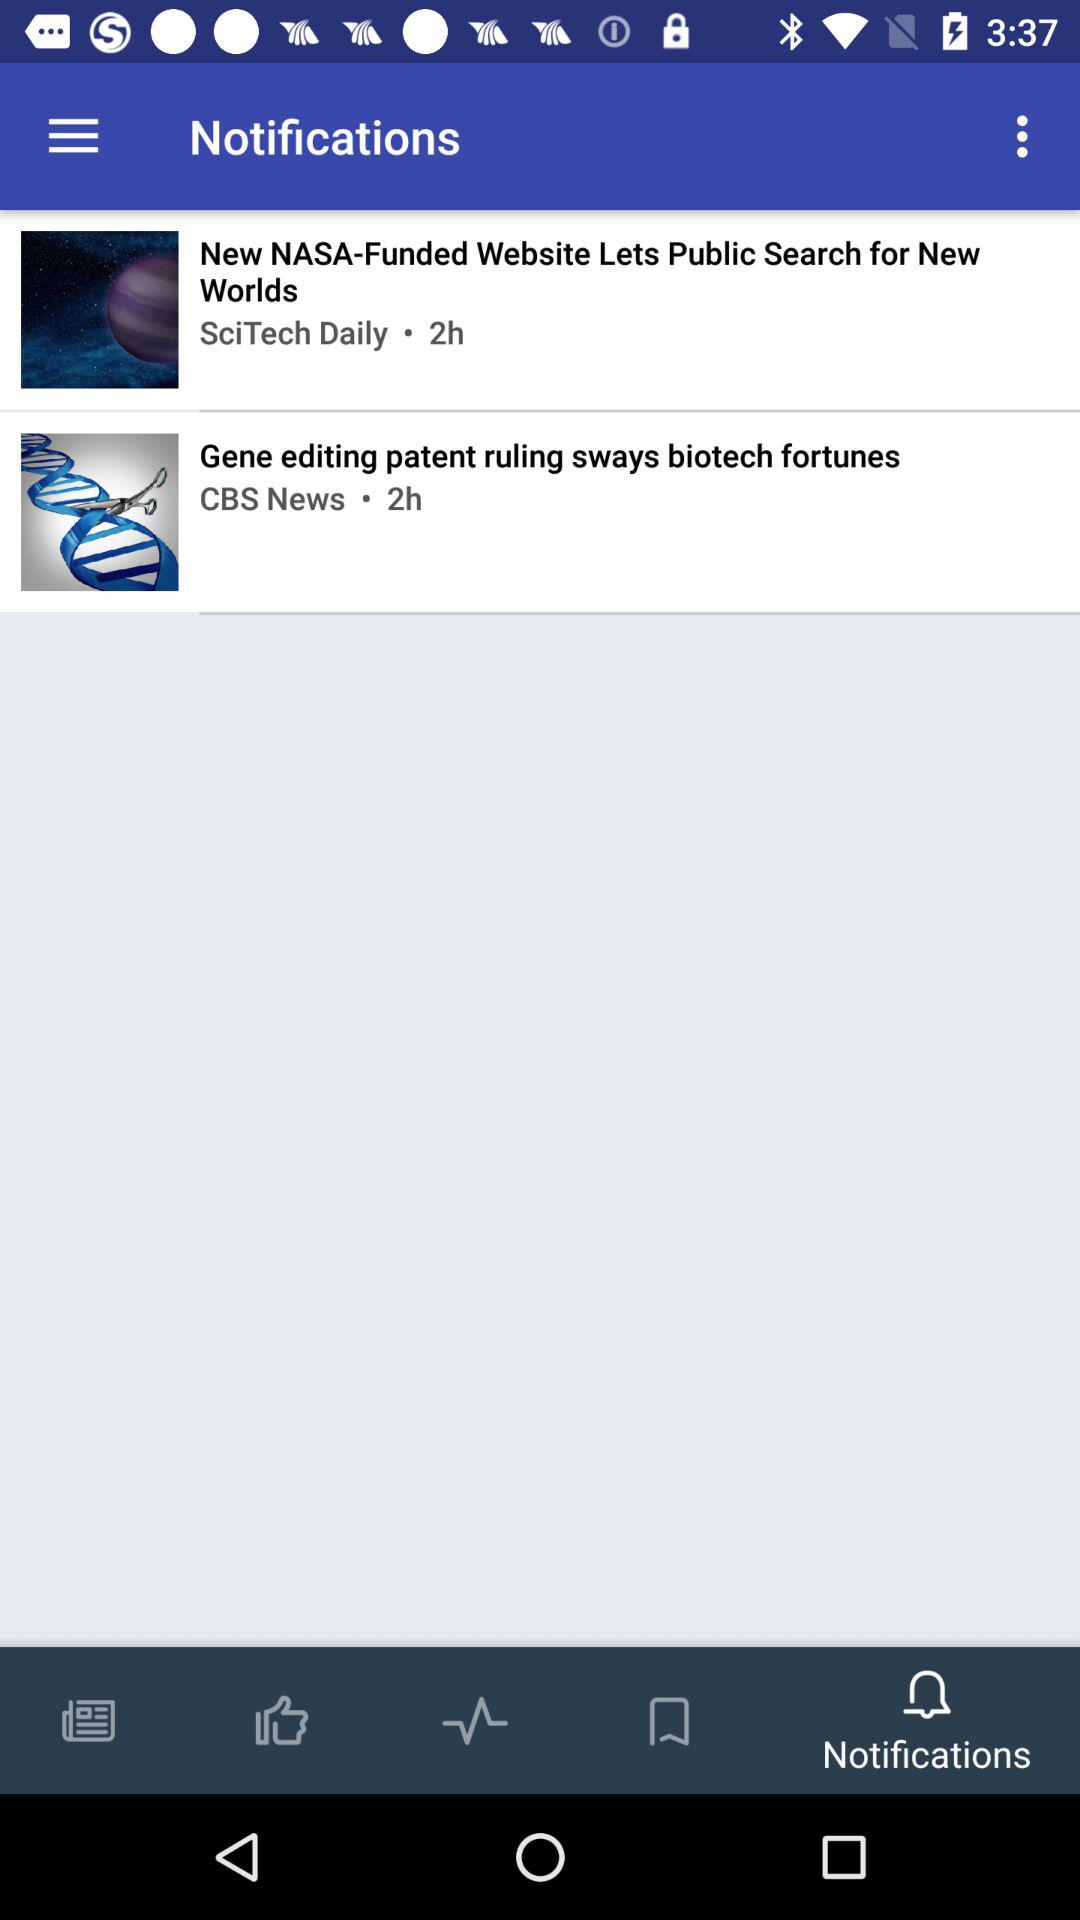When was the news "New NASA-Funded Website Lets Public Search for New Worlds" posted? The news "New NASA-Funded Website Lets Public Search for New Worlds" was posted 2 hours ago. 